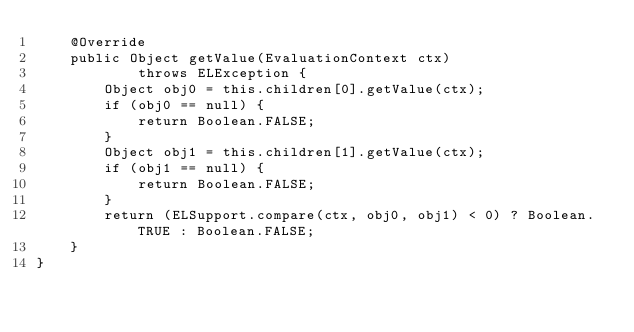Convert code to text. <code><loc_0><loc_0><loc_500><loc_500><_Java_>    @Override
    public Object getValue(EvaluationContext ctx)
            throws ELException {
        Object obj0 = this.children[0].getValue(ctx);
        if (obj0 == null) {
            return Boolean.FALSE;
        }
        Object obj1 = this.children[1].getValue(ctx);
        if (obj1 == null) {
            return Boolean.FALSE;
        }
        return (ELSupport.compare(ctx, obj0, obj1) < 0) ? Boolean.TRUE : Boolean.FALSE;
    }
}
</code> 